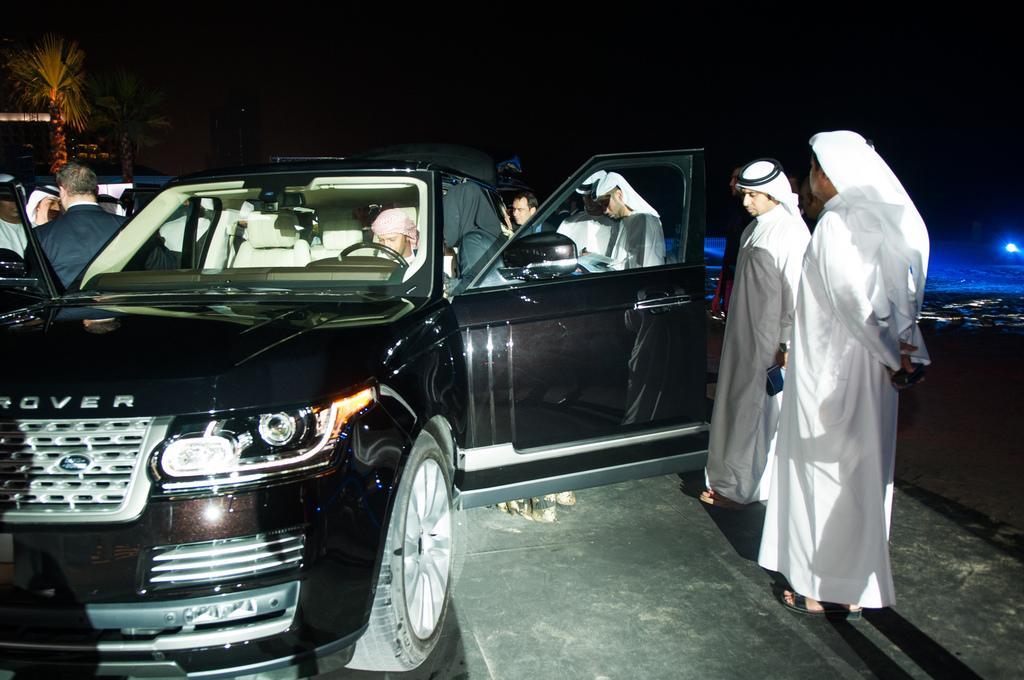Can you describe this image briefly? In this picture there is a black color car and in the car there is a person and around the car there are some people in the white color dress. 